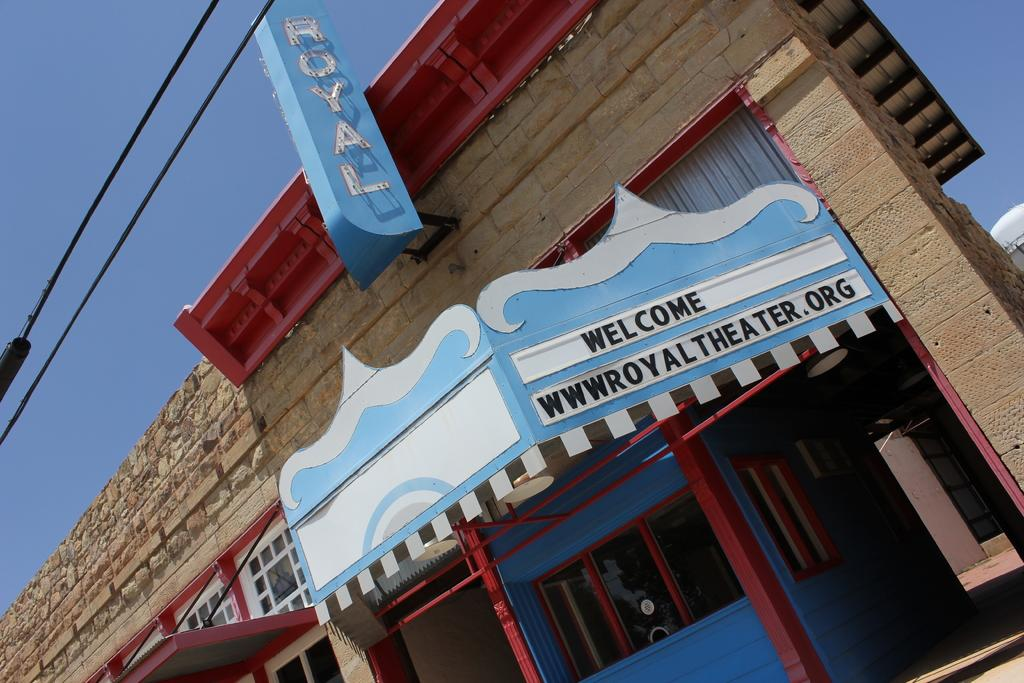Provide a one-sentence caption for the provided image. The entrance of the building which has the writing Welcome wwwroyaltheater.org. 